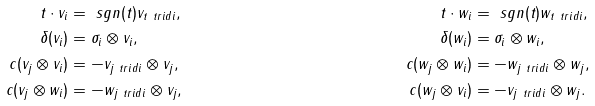<formula> <loc_0><loc_0><loc_500><loc_500>t \cdot v _ { i } & = \ s g n ( t ) v _ { t \ t r i d i } , & \, t \cdot w _ { i } & = \ s g n ( t ) w _ { t \ t r i d i } , \\ \delta ( v _ { i } ) & = \sigma _ { i } \otimes v _ { i } , & \, \delta ( w _ { i } ) & = \sigma _ { i } \otimes w _ { i } , \\ c ( v _ { j } \otimes v _ { i } ) & = - v _ { j \ t r i d i } \otimes v _ { j } , & \, c ( w _ { j } \otimes w _ { i } ) & = - w _ { j \ t r i d i } \otimes w _ { j } , \\ c ( v _ { j } \otimes w _ { i } ) & = - w _ { j \ t r i d i } \otimes v _ { j } , & \, c ( w _ { j } \otimes v _ { i } ) & = - v _ { j \ t r i d i } \otimes w _ { j } .</formula> 